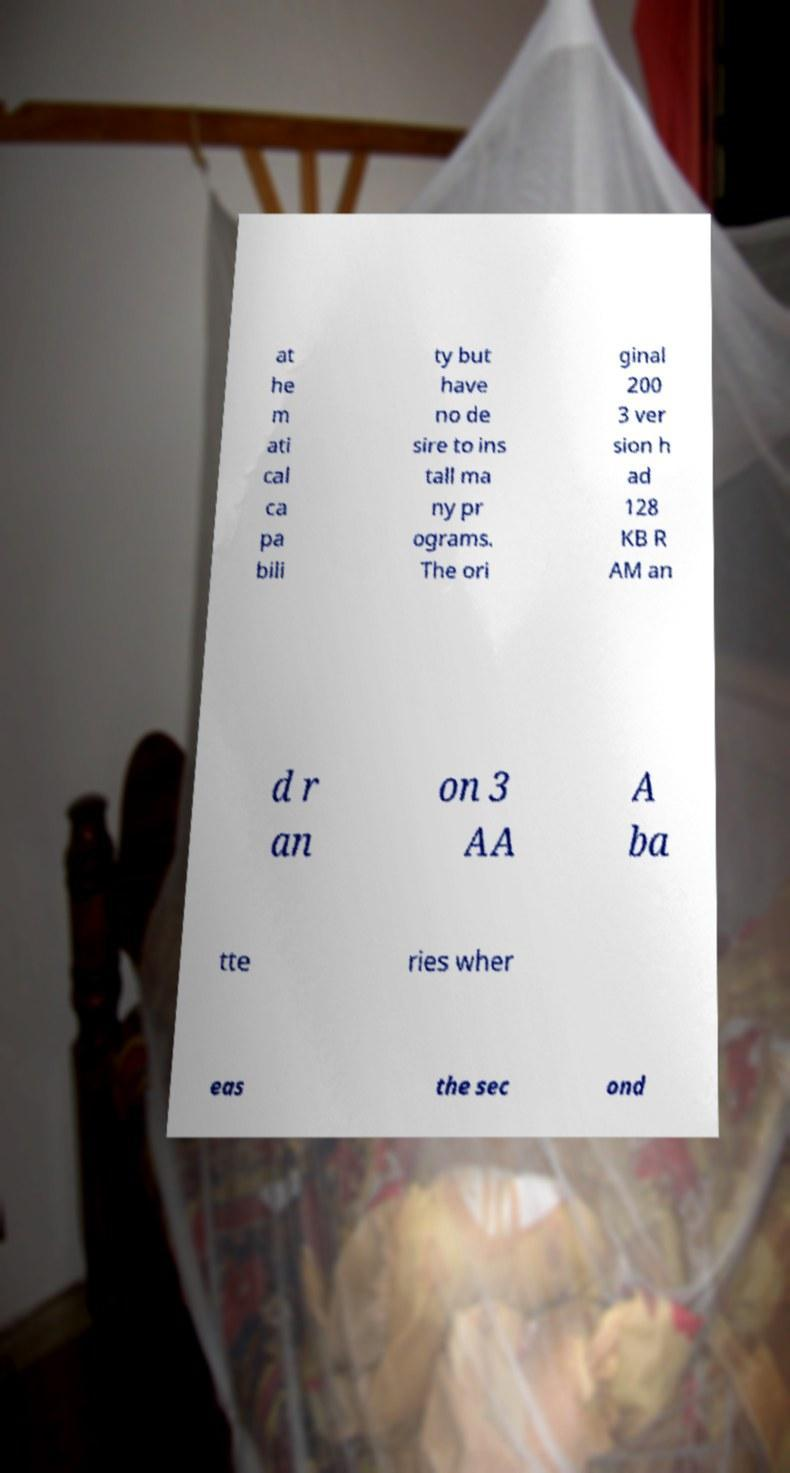What messages or text are displayed in this image? I need them in a readable, typed format. at he m ati cal ca pa bili ty but have no de sire to ins tall ma ny pr ograms. The ori ginal 200 3 ver sion h ad 128 KB R AM an d r an on 3 AA A ba tte ries wher eas the sec ond 